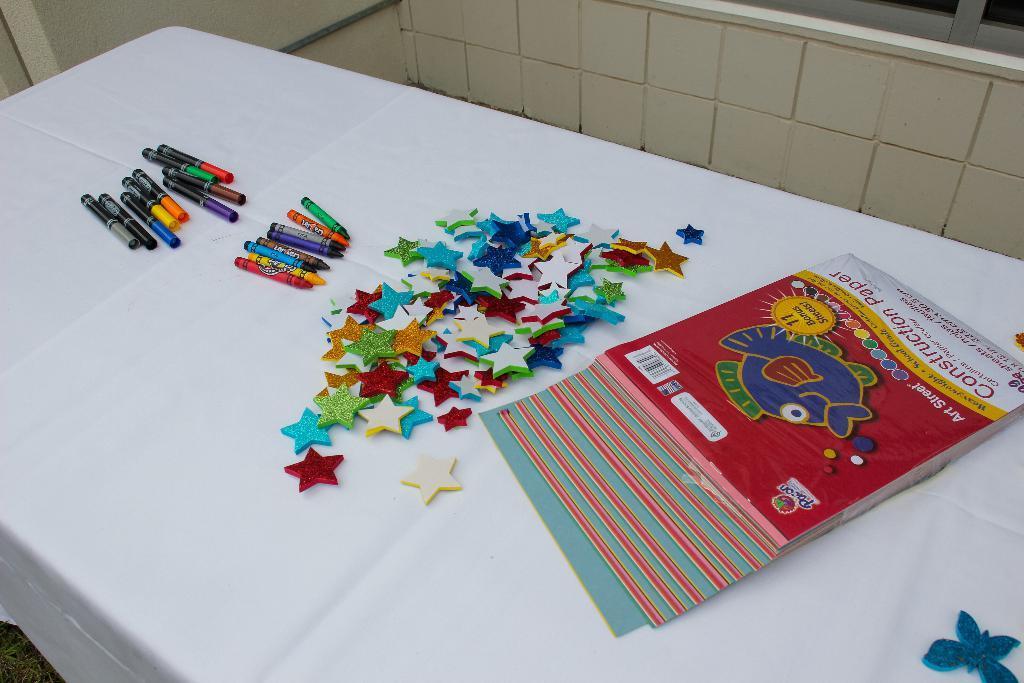Can you describe this image briefly? In this picture we can see books, crayons and some objects are placed on a white cloth and this cloth is placed on a table and in the background we can see the wall. 